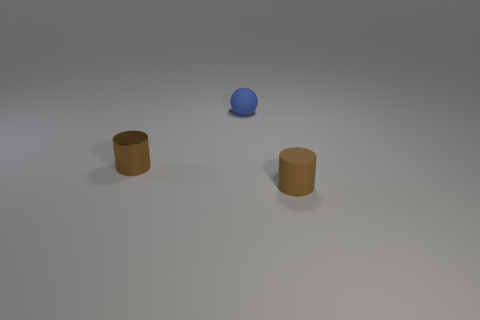Is the number of brown cylinders greater than the number of blue matte spheres?
Your response must be concise. Yes. There is another small brown object that is the same shape as the brown rubber thing; what is its material?
Make the answer very short. Metal. Are there more blue rubber balls behind the small brown rubber thing than big purple objects?
Give a very brief answer. Yes. What is the material of the tiny cylinder that is on the left side of the matte thing behind the brown thing that is on the left side of the small matte sphere?
Provide a succinct answer. Metal. How many objects are either tiny metallic cylinders or tiny blue things that are behind the brown metallic cylinder?
Your response must be concise. 2. There is a small cylinder behind the brown rubber object; is its color the same as the small rubber cylinder?
Make the answer very short. Yes. Are there more small brown rubber cylinders in front of the tiny sphere than shiny cylinders that are right of the brown metallic cylinder?
Provide a short and direct response. Yes. Are there any other things of the same color as the tiny shiny object?
Your answer should be very brief. Yes. What number of things are either tiny purple spheres or metallic cylinders?
Provide a succinct answer. 1. There is a rubber thing to the left of the rubber cylinder; is it the same size as the brown metallic thing?
Give a very brief answer. Yes. 